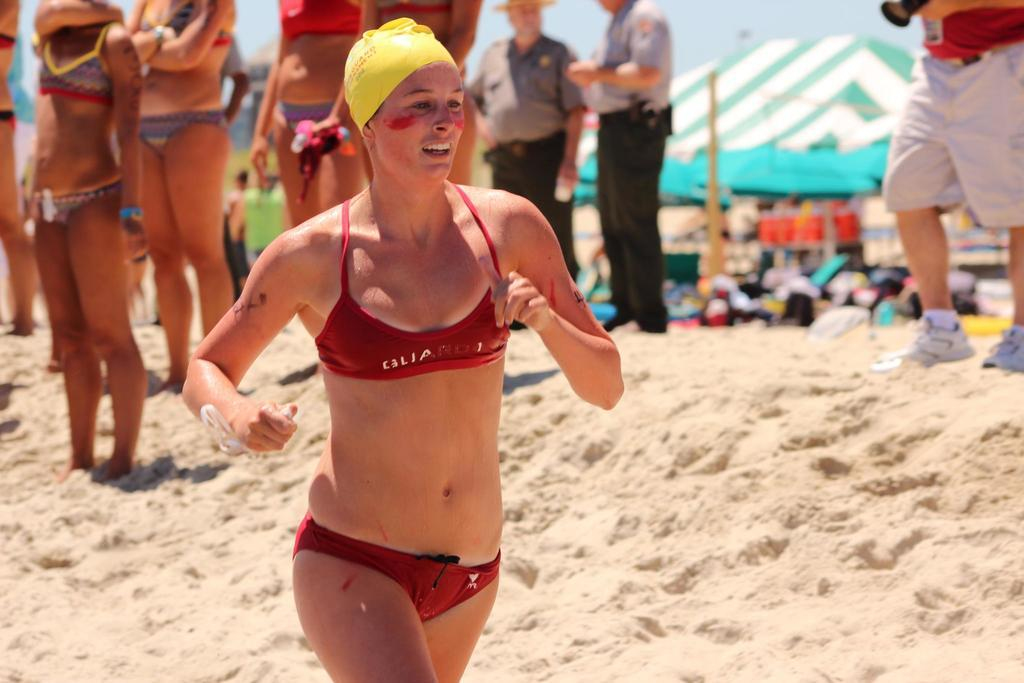What is the surface that the people are standing on in the image? The people are standing on sand in the image. What can be seen in the background of the image? There are tents in the background of the image. How would you describe the background of the image? The background is blurred. What is the name of the person standing on the left side of the image? There is no specific person mentioned in the image, so it is not possible to determine their name. 